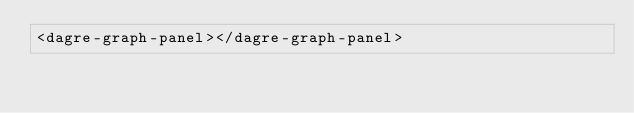Convert code to text. <code><loc_0><loc_0><loc_500><loc_500><_HTML_><dagre-graph-panel></dagre-graph-panel>
</code> 